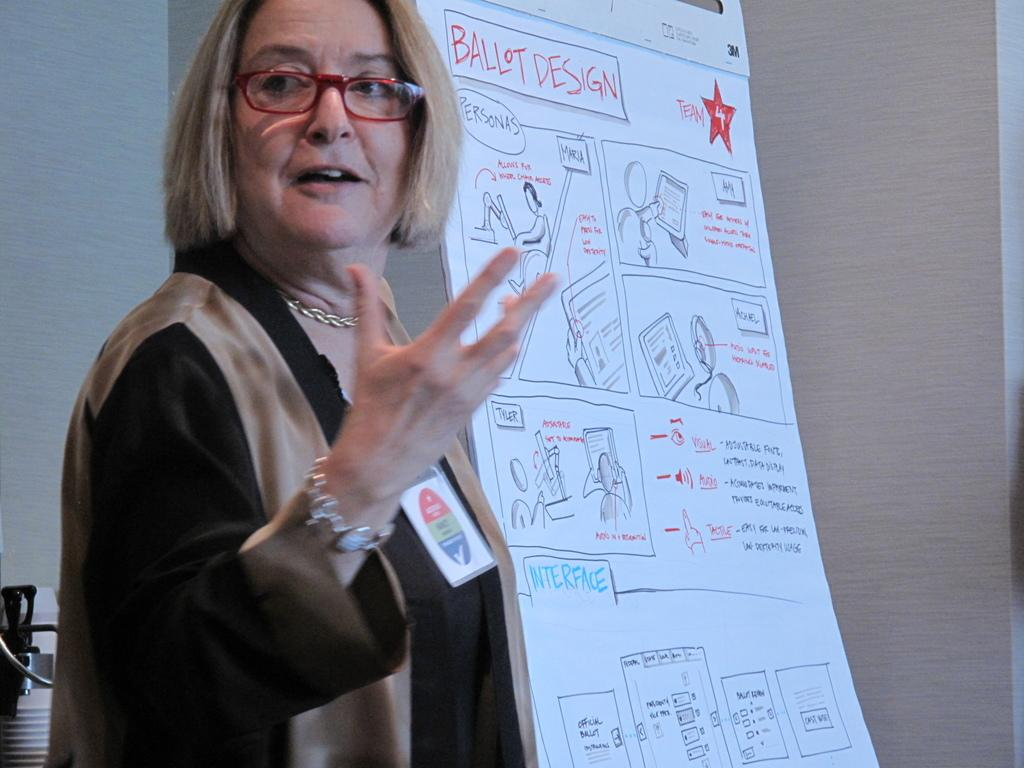Who or what is present in the image? There is a person in the image. Can you describe the person's appearance? The person is wearing spectacles. What else can be seen in the image besides the person? There is a board with images and text, a wall, and objects on the left side of the image. What type of house does the bee live in, as seen in the image? There is no bee or house present in the image. Can you describe the servant's duties in the image? There is no servant present in the image. 